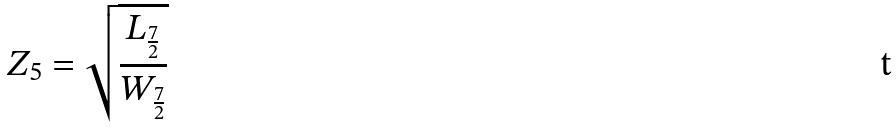<formula> <loc_0><loc_0><loc_500><loc_500>Z _ { 5 } = \sqrt { \frac { L _ { \frac { 7 } { 2 } } } { W _ { \frac { 7 } { 2 } } } }</formula> 